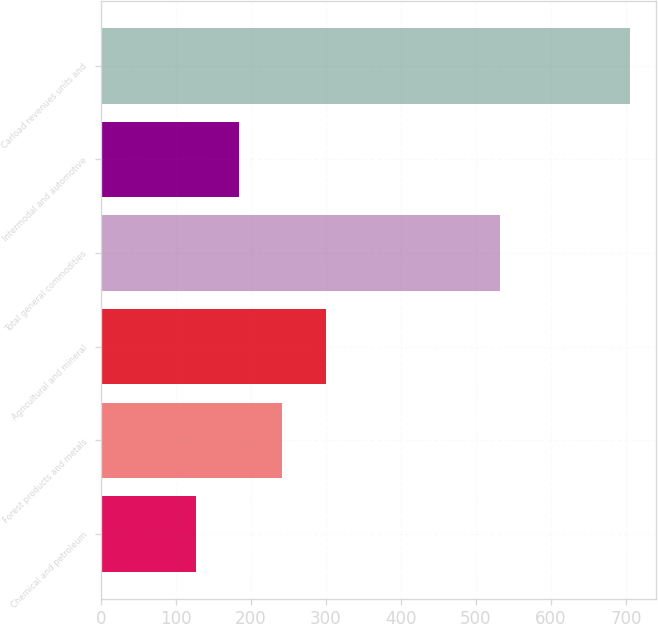<chart> <loc_0><loc_0><loc_500><loc_500><bar_chart><fcel>Chemical and petroleum<fcel>Forest products and metals<fcel>Agricultural and mineral<fcel>Total general commodities<fcel>Intermodal and automotive<fcel>Carload revenues units and<nl><fcel>126.5<fcel>242.18<fcel>300.02<fcel>531.9<fcel>184.34<fcel>704.9<nl></chart> 